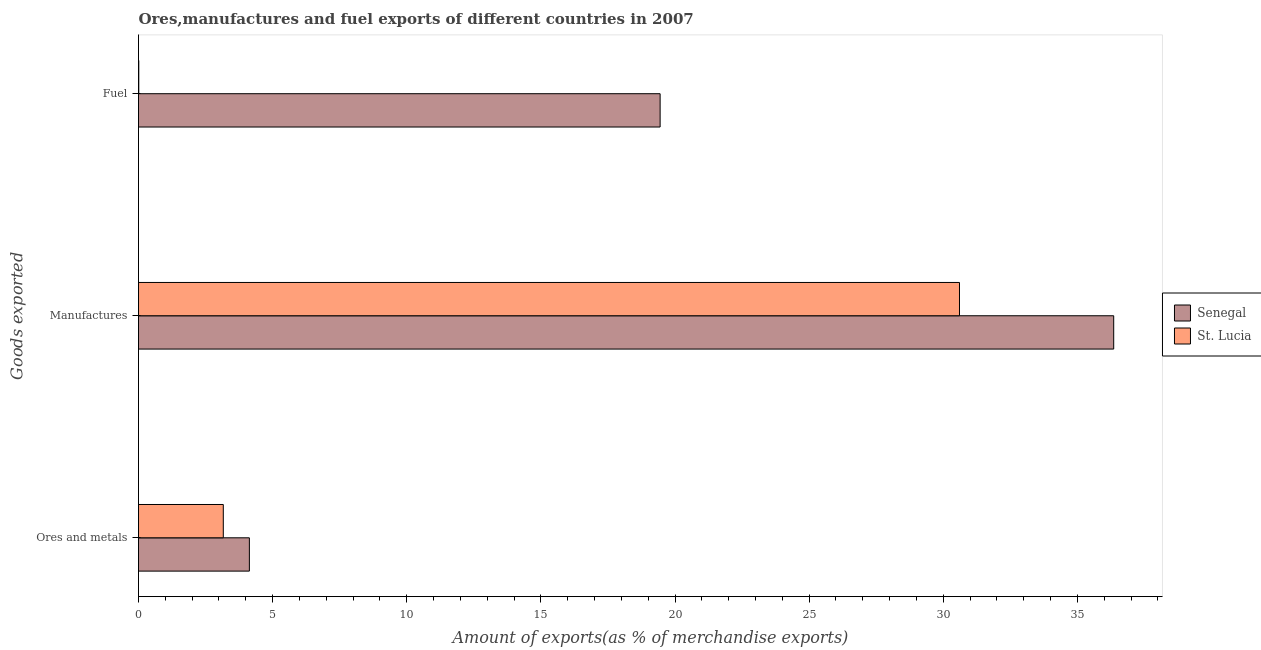Are the number of bars on each tick of the Y-axis equal?
Make the answer very short. Yes. How many bars are there on the 3rd tick from the top?
Provide a succinct answer. 2. What is the label of the 2nd group of bars from the top?
Keep it short and to the point. Manufactures. What is the percentage of fuel exports in Senegal?
Offer a very short reply. 19.44. Across all countries, what is the maximum percentage of fuel exports?
Provide a succinct answer. 19.44. Across all countries, what is the minimum percentage of fuel exports?
Offer a very short reply. 0.01. In which country was the percentage of manufactures exports maximum?
Your answer should be compact. Senegal. In which country was the percentage of fuel exports minimum?
Your answer should be compact. St. Lucia. What is the total percentage of fuel exports in the graph?
Provide a succinct answer. 19.45. What is the difference between the percentage of manufactures exports in St. Lucia and that in Senegal?
Offer a terse response. -5.75. What is the difference between the percentage of manufactures exports in St. Lucia and the percentage of fuel exports in Senegal?
Keep it short and to the point. 11.16. What is the average percentage of fuel exports per country?
Your response must be concise. 9.73. What is the difference between the percentage of ores and metals exports and percentage of manufactures exports in St. Lucia?
Give a very brief answer. -27.44. In how many countries, is the percentage of ores and metals exports greater than 24 %?
Your answer should be compact. 0. What is the ratio of the percentage of fuel exports in St. Lucia to that in Senegal?
Provide a short and direct response. 0. Is the difference between the percentage of fuel exports in St. Lucia and Senegal greater than the difference between the percentage of manufactures exports in St. Lucia and Senegal?
Your response must be concise. No. What is the difference between the highest and the second highest percentage of fuel exports?
Ensure brevity in your answer.  19.43. What is the difference between the highest and the lowest percentage of ores and metals exports?
Ensure brevity in your answer.  0.97. In how many countries, is the percentage of ores and metals exports greater than the average percentage of ores and metals exports taken over all countries?
Your answer should be very brief. 1. Is the sum of the percentage of ores and metals exports in St. Lucia and Senegal greater than the maximum percentage of fuel exports across all countries?
Provide a short and direct response. No. What does the 1st bar from the top in Ores and metals represents?
Your answer should be very brief. St. Lucia. What does the 2nd bar from the bottom in Manufactures represents?
Ensure brevity in your answer.  St. Lucia. Is it the case that in every country, the sum of the percentage of ores and metals exports and percentage of manufactures exports is greater than the percentage of fuel exports?
Ensure brevity in your answer.  Yes. Are all the bars in the graph horizontal?
Your response must be concise. Yes. What is the difference between two consecutive major ticks on the X-axis?
Give a very brief answer. 5. Are the values on the major ticks of X-axis written in scientific E-notation?
Offer a terse response. No. Does the graph contain any zero values?
Make the answer very short. No. Does the graph contain grids?
Your response must be concise. No. How are the legend labels stacked?
Provide a succinct answer. Vertical. What is the title of the graph?
Ensure brevity in your answer.  Ores,manufactures and fuel exports of different countries in 2007. Does "Suriname" appear as one of the legend labels in the graph?
Your response must be concise. No. What is the label or title of the X-axis?
Provide a short and direct response. Amount of exports(as % of merchandise exports). What is the label or title of the Y-axis?
Make the answer very short. Goods exported. What is the Amount of exports(as % of merchandise exports) of Senegal in Ores and metals?
Give a very brief answer. 4.13. What is the Amount of exports(as % of merchandise exports) in St. Lucia in Ores and metals?
Your answer should be compact. 3.16. What is the Amount of exports(as % of merchandise exports) of Senegal in Manufactures?
Make the answer very short. 36.35. What is the Amount of exports(as % of merchandise exports) of St. Lucia in Manufactures?
Offer a very short reply. 30.6. What is the Amount of exports(as % of merchandise exports) of Senegal in Fuel?
Provide a short and direct response. 19.44. What is the Amount of exports(as % of merchandise exports) of St. Lucia in Fuel?
Ensure brevity in your answer.  0.01. Across all Goods exported, what is the maximum Amount of exports(as % of merchandise exports) in Senegal?
Your answer should be compact. 36.35. Across all Goods exported, what is the maximum Amount of exports(as % of merchandise exports) in St. Lucia?
Your answer should be compact. 30.6. Across all Goods exported, what is the minimum Amount of exports(as % of merchandise exports) of Senegal?
Keep it short and to the point. 4.13. Across all Goods exported, what is the minimum Amount of exports(as % of merchandise exports) in St. Lucia?
Offer a very short reply. 0.01. What is the total Amount of exports(as % of merchandise exports) in Senegal in the graph?
Offer a very short reply. 59.93. What is the total Amount of exports(as % of merchandise exports) in St. Lucia in the graph?
Provide a succinct answer. 33.77. What is the difference between the Amount of exports(as % of merchandise exports) of Senegal in Ores and metals and that in Manufactures?
Provide a succinct answer. -32.22. What is the difference between the Amount of exports(as % of merchandise exports) of St. Lucia in Ores and metals and that in Manufactures?
Make the answer very short. -27.44. What is the difference between the Amount of exports(as % of merchandise exports) of Senegal in Ores and metals and that in Fuel?
Your answer should be compact. -15.31. What is the difference between the Amount of exports(as % of merchandise exports) of St. Lucia in Ores and metals and that in Fuel?
Make the answer very short. 3.15. What is the difference between the Amount of exports(as % of merchandise exports) of Senegal in Manufactures and that in Fuel?
Your answer should be very brief. 16.91. What is the difference between the Amount of exports(as % of merchandise exports) of St. Lucia in Manufactures and that in Fuel?
Make the answer very short. 30.59. What is the difference between the Amount of exports(as % of merchandise exports) in Senegal in Ores and metals and the Amount of exports(as % of merchandise exports) in St. Lucia in Manufactures?
Provide a short and direct response. -26.47. What is the difference between the Amount of exports(as % of merchandise exports) in Senegal in Ores and metals and the Amount of exports(as % of merchandise exports) in St. Lucia in Fuel?
Keep it short and to the point. 4.12. What is the difference between the Amount of exports(as % of merchandise exports) in Senegal in Manufactures and the Amount of exports(as % of merchandise exports) in St. Lucia in Fuel?
Keep it short and to the point. 36.34. What is the average Amount of exports(as % of merchandise exports) of Senegal per Goods exported?
Keep it short and to the point. 19.98. What is the average Amount of exports(as % of merchandise exports) of St. Lucia per Goods exported?
Your response must be concise. 11.26. What is the difference between the Amount of exports(as % of merchandise exports) of Senegal and Amount of exports(as % of merchandise exports) of St. Lucia in Ores and metals?
Provide a succinct answer. 0.97. What is the difference between the Amount of exports(as % of merchandise exports) in Senegal and Amount of exports(as % of merchandise exports) in St. Lucia in Manufactures?
Ensure brevity in your answer.  5.75. What is the difference between the Amount of exports(as % of merchandise exports) of Senegal and Amount of exports(as % of merchandise exports) of St. Lucia in Fuel?
Your response must be concise. 19.43. What is the ratio of the Amount of exports(as % of merchandise exports) in Senegal in Ores and metals to that in Manufactures?
Provide a short and direct response. 0.11. What is the ratio of the Amount of exports(as % of merchandise exports) of St. Lucia in Ores and metals to that in Manufactures?
Your response must be concise. 0.1. What is the ratio of the Amount of exports(as % of merchandise exports) in Senegal in Ores and metals to that in Fuel?
Keep it short and to the point. 0.21. What is the ratio of the Amount of exports(as % of merchandise exports) in St. Lucia in Ores and metals to that in Fuel?
Your response must be concise. 319.73. What is the ratio of the Amount of exports(as % of merchandise exports) of Senegal in Manufactures to that in Fuel?
Your answer should be compact. 1.87. What is the ratio of the Amount of exports(as % of merchandise exports) in St. Lucia in Manufactures to that in Fuel?
Your response must be concise. 3096.12. What is the difference between the highest and the second highest Amount of exports(as % of merchandise exports) of Senegal?
Make the answer very short. 16.91. What is the difference between the highest and the second highest Amount of exports(as % of merchandise exports) of St. Lucia?
Ensure brevity in your answer.  27.44. What is the difference between the highest and the lowest Amount of exports(as % of merchandise exports) in Senegal?
Keep it short and to the point. 32.22. What is the difference between the highest and the lowest Amount of exports(as % of merchandise exports) of St. Lucia?
Make the answer very short. 30.59. 